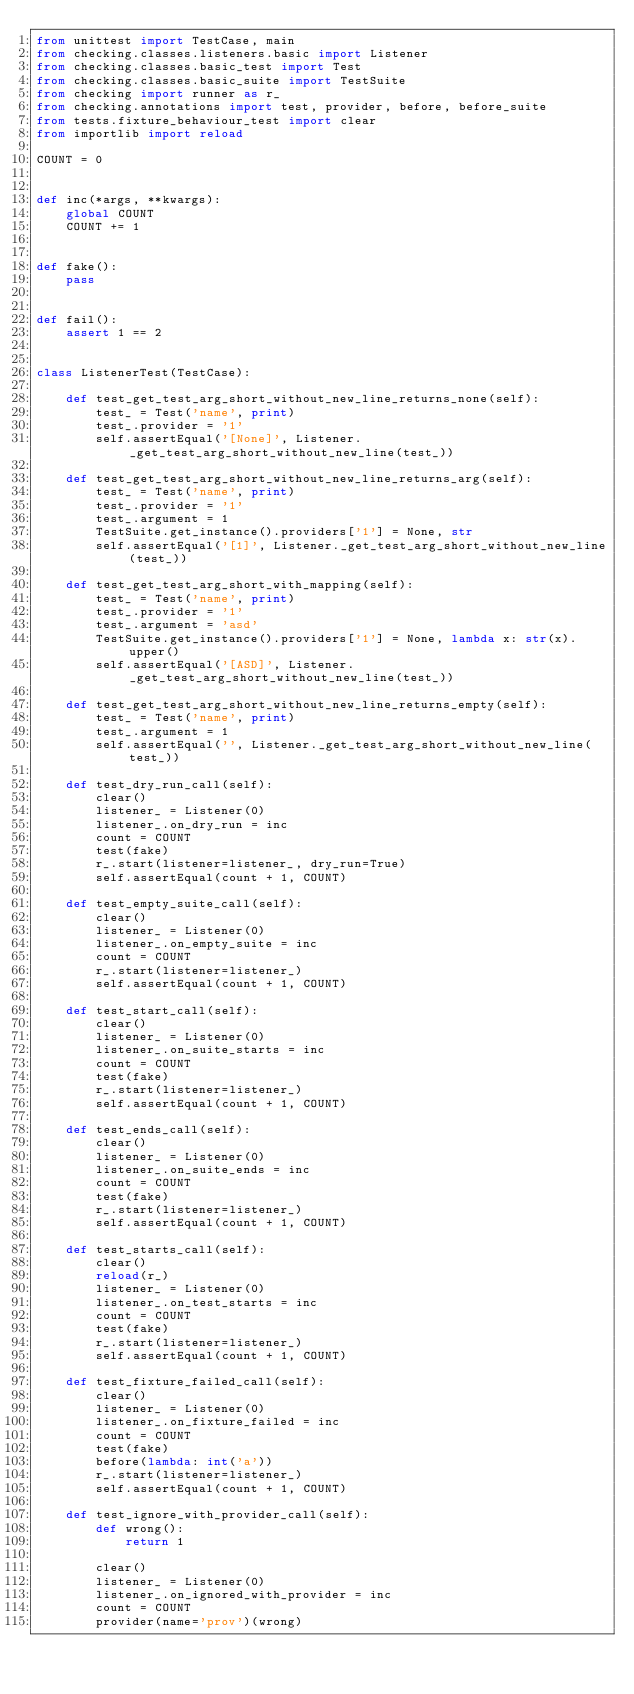Convert code to text. <code><loc_0><loc_0><loc_500><loc_500><_Python_>from unittest import TestCase, main
from checking.classes.listeners.basic import Listener
from checking.classes.basic_test import Test
from checking.classes.basic_suite import TestSuite
from checking import runner as r_
from checking.annotations import test, provider, before, before_suite
from tests.fixture_behaviour_test import clear
from importlib import reload

COUNT = 0


def inc(*args, **kwargs):
    global COUNT
    COUNT += 1


def fake():
    pass


def fail():
    assert 1 == 2


class ListenerTest(TestCase):

    def test_get_test_arg_short_without_new_line_returns_none(self):
        test_ = Test('name', print)
        test_.provider = '1'
        self.assertEqual('[None]', Listener._get_test_arg_short_without_new_line(test_))

    def test_get_test_arg_short_without_new_line_returns_arg(self):
        test_ = Test('name', print)
        test_.provider = '1'
        test_.argument = 1
        TestSuite.get_instance().providers['1'] = None, str
        self.assertEqual('[1]', Listener._get_test_arg_short_without_new_line(test_))

    def test_get_test_arg_short_with_mapping(self):
        test_ = Test('name', print)
        test_.provider = '1'
        test_.argument = 'asd'
        TestSuite.get_instance().providers['1'] = None, lambda x: str(x).upper()
        self.assertEqual('[ASD]', Listener._get_test_arg_short_without_new_line(test_))

    def test_get_test_arg_short_without_new_line_returns_empty(self):
        test_ = Test('name', print)
        test_.argument = 1
        self.assertEqual('', Listener._get_test_arg_short_without_new_line(test_))

    def test_dry_run_call(self):
        clear()
        listener_ = Listener(0)
        listener_.on_dry_run = inc
        count = COUNT
        test(fake)
        r_.start(listener=listener_, dry_run=True)
        self.assertEqual(count + 1, COUNT)

    def test_empty_suite_call(self):
        clear()
        listener_ = Listener(0)
        listener_.on_empty_suite = inc
        count = COUNT
        r_.start(listener=listener_)
        self.assertEqual(count + 1, COUNT)

    def test_start_call(self):
        clear()
        listener_ = Listener(0)
        listener_.on_suite_starts = inc
        count = COUNT
        test(fake)
        r_.start(listener=listener_)
        self.assertEqual(count + 1, COUNT)

    def test_ends_call(self):
        clear()
        listener_ = Listener(0)
        listener_.on_suite_ends = inc
        count = COUNT
        test(fake)
        r_.start(listener=listener_)
        self.assertEqual(count + 1, COUNT)

    def test_starts_call(self):
        clear()
        reload(r_)
        listener_ = Listener(0)
        listener_.on_test_starts = inc
        count = COUNT
        test(fake)
        r_.start(listener=listener_)
        self.assertEqual(count + 1, COUNT)

    def test_fixture_failed_call(self):
        clear()
        listener_ = Listener(0)
        listener_.on_fixture_failed = inc
        count = COUNT
        test(fake)
        before(lambda: int('a'))
        r_.start(listener=listener_)
        self.assertEqual(count + 1, COUNT)

    def test_ignore_with_provider_call(self):
        def wrong():
            return 1

        clear()
        listener_ = Listener(0)
        listener_.on_ignored_with_provider = inc
        count = COUNT
        provider(name='prov')(wrong)</code> 